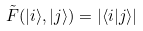<formula> <loc_0><loc_0><loc_500><loc_500>\tilde { F } ( | i \rangle , | j \rangle ) = | \langle i | j \rangle |</formula> 